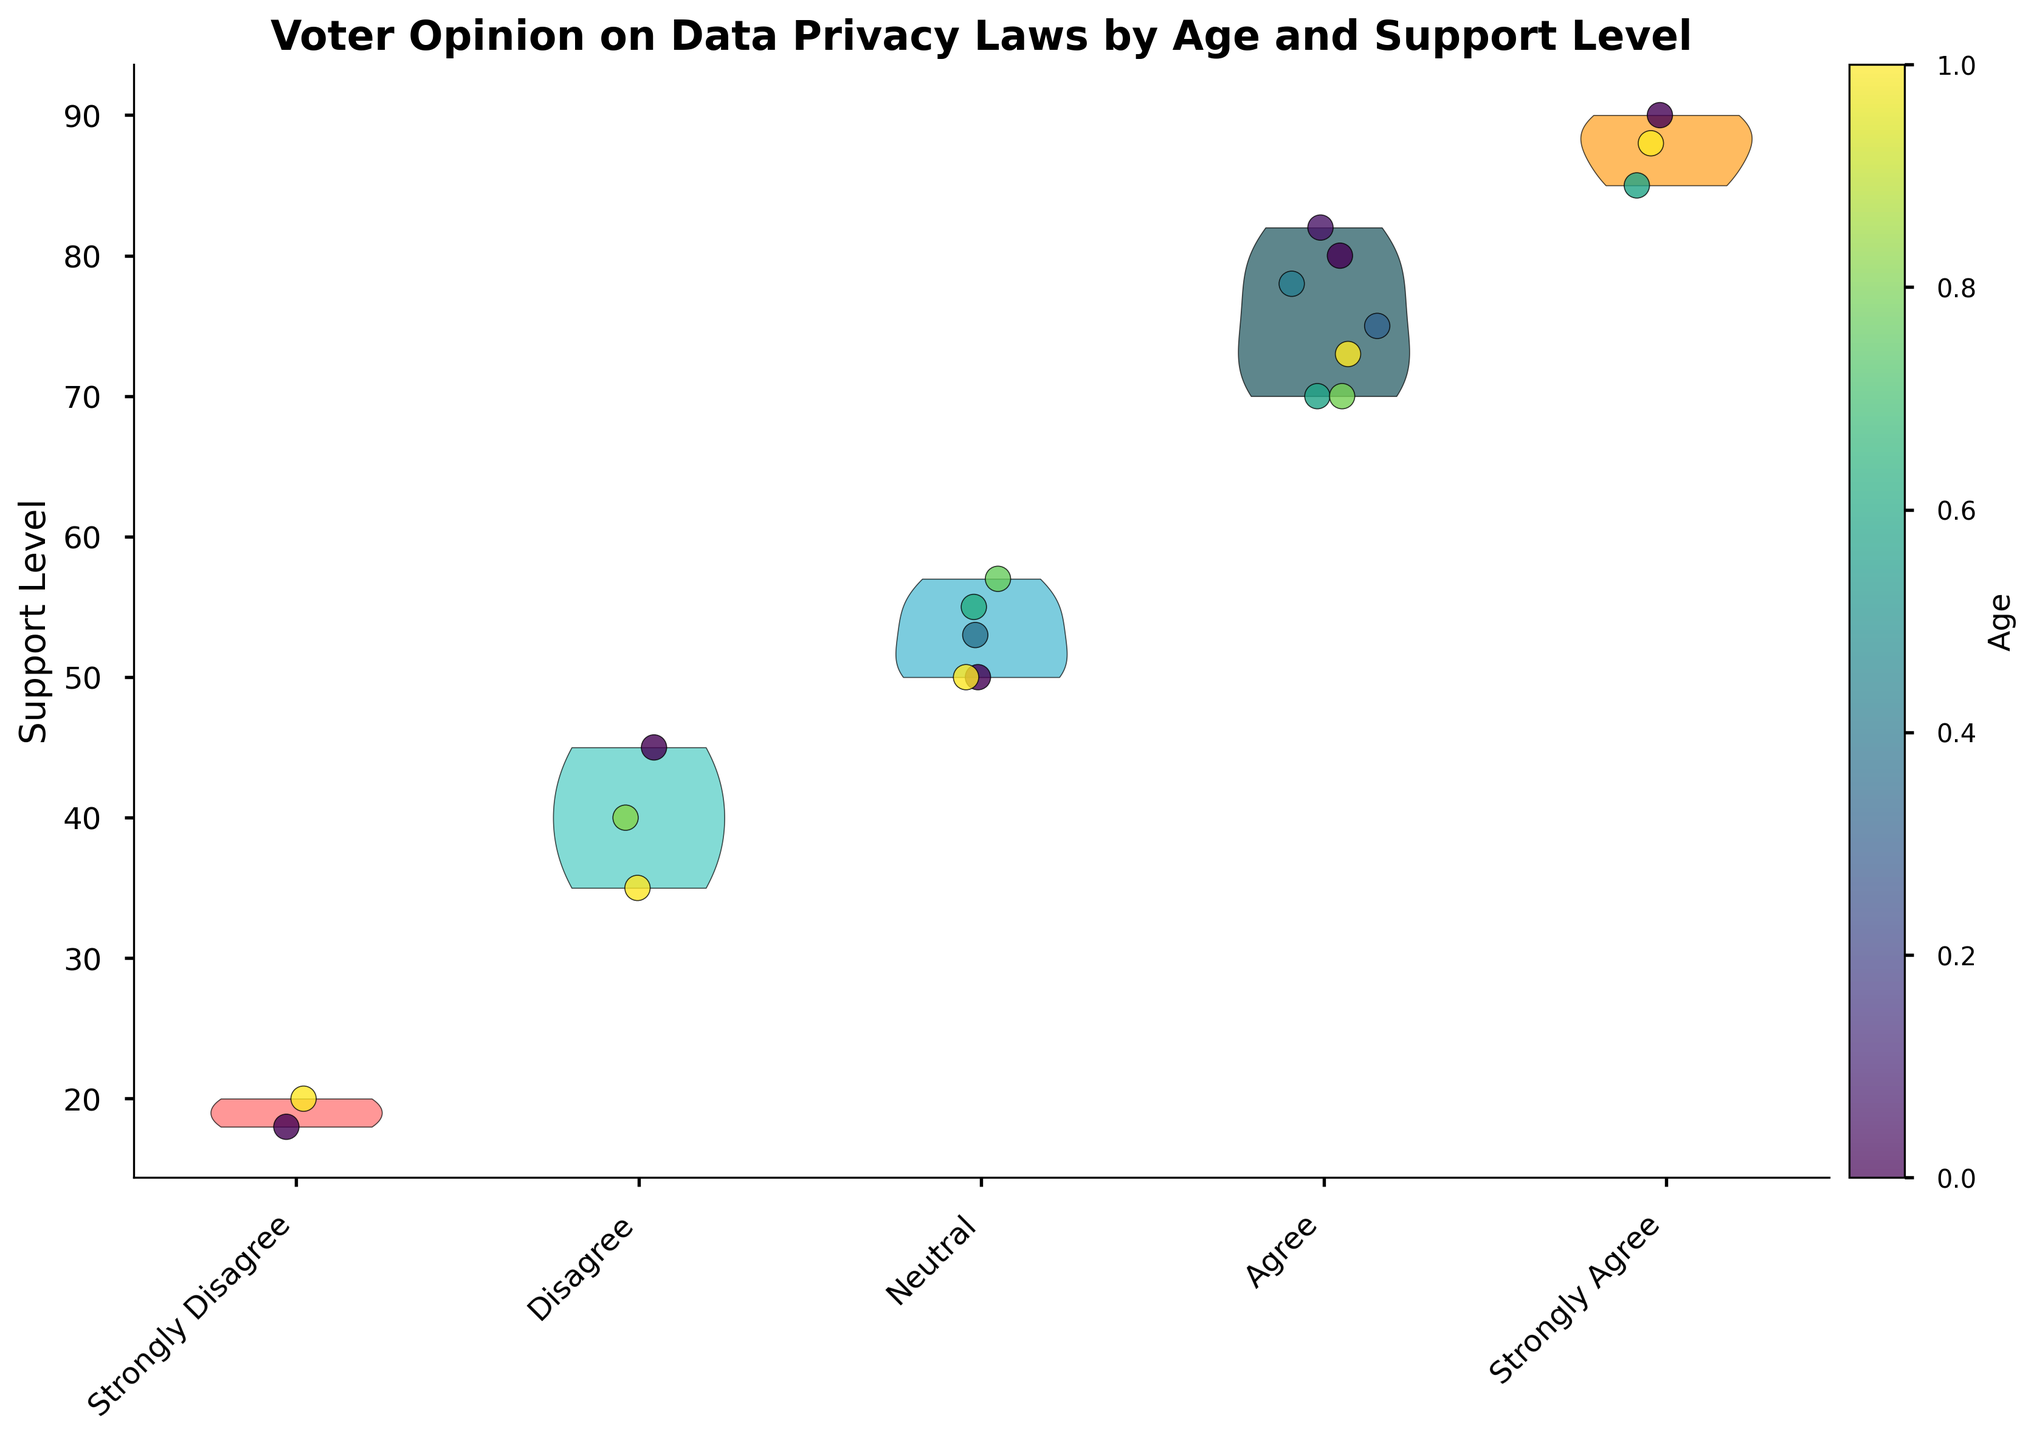What is the title of the figure? The title is usually placed at the top of the figure. In this case, it says 'Voter Opinion on Data Privacy Laws by Age and Support Level'.
Answer: Voter Opinion on Data Privacy Laws by Age and Support Level What age range is represented in the figure? Referring to the color bar and scatter points in the plot, the range of ages represented is from the minimum to the maximum value shown on the color bar.
Answer: 18-63 How many opinion categories are there in the figure? There are different colors and labels corresponding to each category of opinions on the x-axis. Counting these labels gives the number of categories.
Answer: 5 Which opinion category seems to have the highest median support level? By looking at the density and central tendency of the violin plots, we can estimate which group’s central value is higher. It appears that the 'Strongly Agree' category has the highest median.
Answer: Strongly Agree How do the support levels for "Disagree" compare to "Neutral"? Compare the range and distribution of the support levels between the 'Disagree' and 'Neutral' opinion categories. 'Disagree' tends to have lower values than 'Neutral'.
Answer: Disagree has lower support levels than Neutral What color represents voters in their 20s? The color bar on the right side shows the gradient used for different age groups, and we can match the color to determine the age range.
Answer: Greenish-yellow What is the support level range for "Strongly Disagree"? By looking at the violin plot for 'Strongly Disagree,' observe the spread of points to determine the minimum and maximum support levels within this category.
Answer: 18-20 Which age group appears to have the most scattered opinions? Examine the distribution of colors in the scatter points, particularly focusing on how spread out they are within each opinion category.
Answer: Voters in their 20s Is there any overlap in support levels between "Agree" and "Strongly Agree"? Compare the span of the violin plots for both 'Agree' and 'Strongly Agree' categories to see if their support levels intersect.
Answer: Yes What's the maximum support level among "Agree" voters? Identify the highest vertical point within the 'Agree' category on the scatter plot to determine the maximum support level.
Answer: 82 